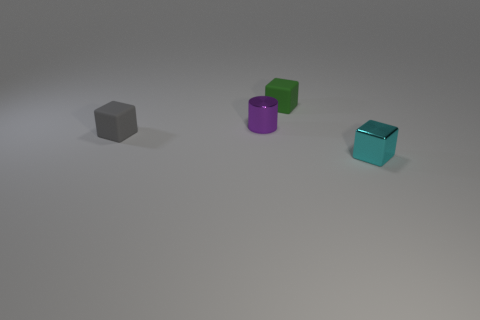Add 1 gray rubber blocks. How many objects exist? 5 Subtract all cylinders. How many objects are left? 3 Subtract all purple shiny objects. Subtract all purple cylinders. How many objects are left? 2 Add 2 rubber objects. How many rubber objects are left? 4 Add 4 balls. How many balls exist? 4 Subtract 1 purple cylinders. How many objects are left? 3 